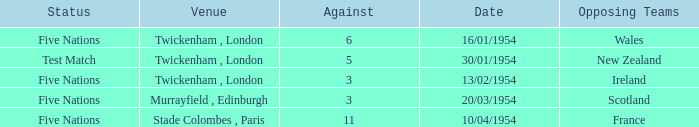What was the venue for the game played on 16/01/1954, when the against was more than 3? Twickenham , London. Write the full table. {'header': ['Status', 'Venue', 'Against', 'Date', 'Opposing Teams'], 'rows': [['Five Nations', 'Twickenham , London', '6', '16/01/1954', 'Wales'], ['Test Match', 'Twickenham , London', '5', '30/01/1954', 'New Zealand'], ['Five Nations', 'Twickenham , London', '3', '13/02/1954', 'Ireland'], ['Five Nations', 'Murrayfield , Edinburgh', '3', '20/03/1954', 'Scotland'], ['Five Nations', 'Stade Colombes , Paris', '11', '10/04/1954', 'France']]} 